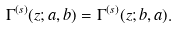<formula> <loc_0><loc_0><loc_500><loc_500>\Gamma ^ { ( s ) } ( z ; a , b ) = \Gamma ^ { ( s ) } ( z ; b , a ) .</formula> 